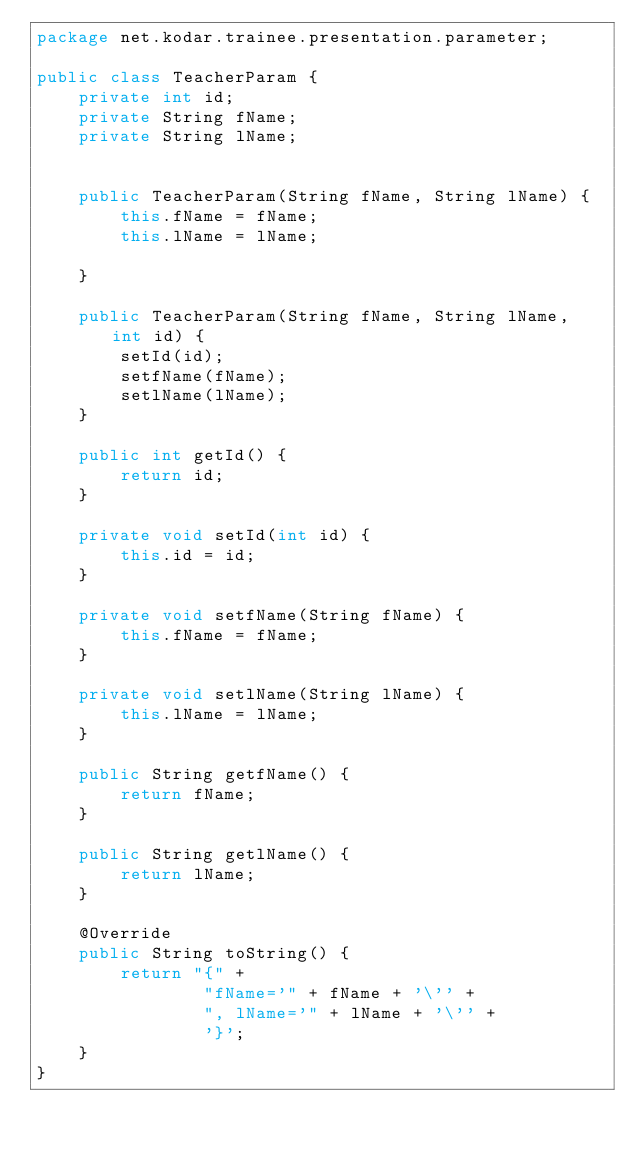Convert code to text. <code><loc_0><loc_0><loc_500><loc_500><_Java_>package net.kodar.trainee.presentation.parameter;

public class TeacherParam {
    private int id;
    private String fName;
    private String lName;


    public TeacherParam(String fName, String lName) {
        this.fName = fName;
        this.lName = lName;

    }

    public TeacherParam(String fName, String lName, int id) {
        setId(id);
        setfName(fName);
        setlName(lName);
    }

    public int getId() {
        return id;
    }

    private void setId(int id) {
        this.id = id;
    }

    private void setfName(String fName) {
        this.fName = fName;
    }

    private void setlName(String lName) {
        this.lName = lName;
    }

    public String getfName() {
        return fName;
    }

    public String getlName() {
        return lName;
    }

    @Override
    public String toString() {
        return "{" +
                "fName='" + fName + '\'' +
                ", lName='" + lName + '\'' +
                '}';
    }
}
</code> 